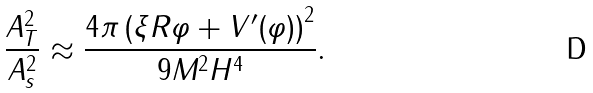Convert formula to latex. <formula><loc_0><loc_0><loc_500><loc_500>\frac { A _ { T } ^ { 2 } } { A _ { s } ^ { 2 } } \approx \frac { 4 \pi \left ( \xi R \varphi + V ^ { \prime } ( \varphi ) \right ) ^ { 2 } } { 9 M ^ { 2 } H ^ { 4 } } .</formula> 